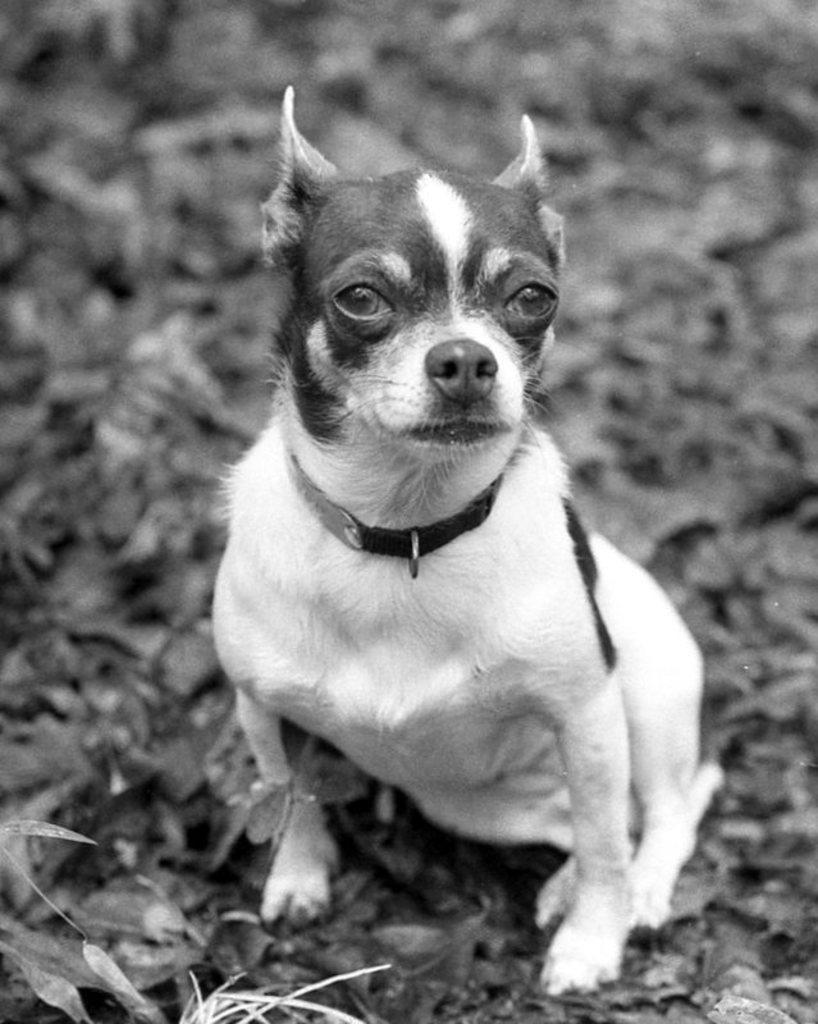In one or two sentences, can you explain what this image depicts? In this image we can see a dog which is white in color. 